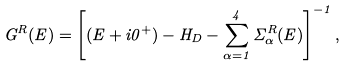Convert formula to latex. <formula><loc_0><loc_0><loc_500><loc_500>G ^ { R } ( E ) = \left [ ( E + i 0 ^ { + } ) - H _ { D } - \sum _ { \alpha = 1 } ^ { 4 } \Sigma _ { \alpha } ^ { R } ( E ) \right ] ^ { - 1 } ,</formula> 